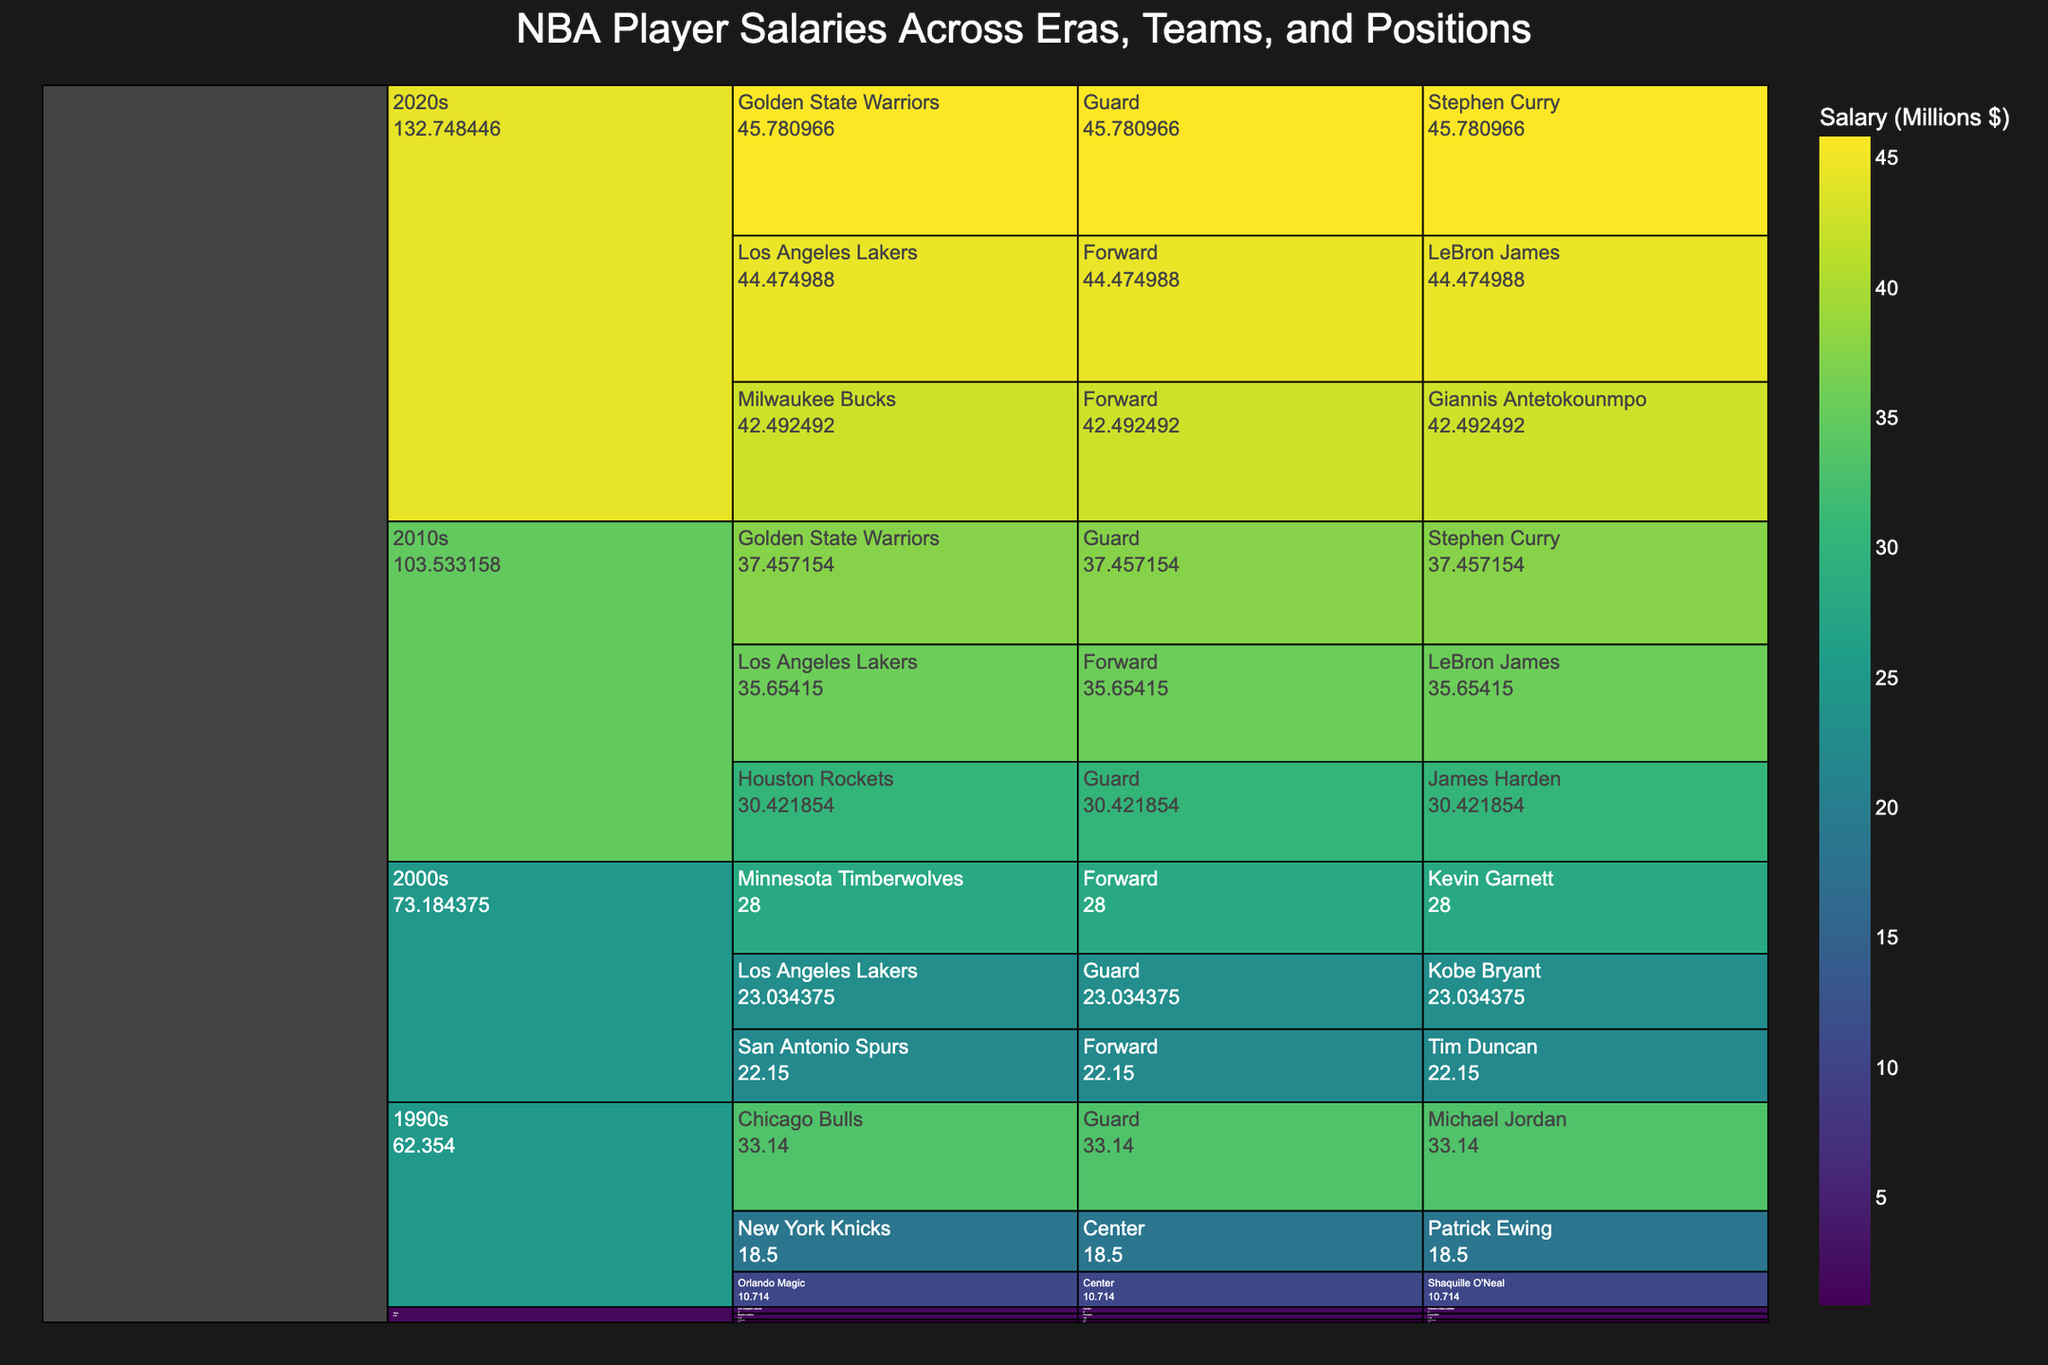what is the title of the icicle chart? The title of a chart can usually be found at the top. Here, it is explicitly set in the code.
Answer: NBA Player Salaries Across Eras, Teams, and Positions Which player has the highest salary in the 2020s era? In the 2020s era, the icicle chart will show the breakdown by teams, positions, and players. By following the highest node under 2020s, we find the highest salary.
Answer: Stephen Curry How does LeBron James' salary in the 2010s compare to his salary in the 2020s? LeBron James' salaries will be shown under the respective eras. By comparing values under 2010s and 2020s, we find: $35.65M in 2010s vs $44.47M in 2020s.
Answer: Higher in the 2020s Which team in the 2000s era shows the highest aggregate salary? Aggregate salaries for teams are represented by the size of nodes. Summing up each player's salary for their respective teams in the era: Lakers (23.03), Timberwolves (28.00), and Spurs (22.15).
Answer: Minnesota Timberwolves What's the total salary for guards across all eras? We need to sum up the salaries for players categorized as Guards: Michael Jordan ('80s, '90s), Kobe Bryant, Stephen Curry ('10s, '20s), James Harden.
Answer: $171,478,974 (171.48 million) Identify the era with the lowest maximum player salary. For each era, identify the player with the maximum salary and compare them: '80s ($2M), '90s ($33.14M), '00s ($28M), '10s ($37.46M), '20s ($45.78M).
Answer: 1980s Which position has the highest cumulative salary in the 2010s era? Sum the salaries for each position within the 2010s: Guards (Stephen Curry $37.46M + James Harden $30.42M), Forwards (LeBron James $35.65M).
Answer: Guards Compare the salary of Michael Jordan in the 1980s and 1990s and calculate the percentage increase. Jordan's salary in the '80s ($0.85M) and '90s ($33.14M). Percentage increase = [(33.14 - 0.85) / 0.85] * 100.
Answer: 3,800% How does the salary distribution in the 1980s compare to the 2000s? By reviewing the node sizes and values under both eras, we find the highest salaries in the '80s were much lower compared to those in the 2000s.
Answer: Much lower in the 1980s Which player appears in multiple eras, and what are their salaries in each era? Identifying players listed under multiple eras: Michael Jordan (80s - $0.85M, 90s - $33.14M); Stephen Curry (10s - $37.46M, 20s - $45.78M); LeBron James (10s - $35.65M, 20s - $44.47M).
Answer: Michael Jordan, Stephen Curry, LeBron James 